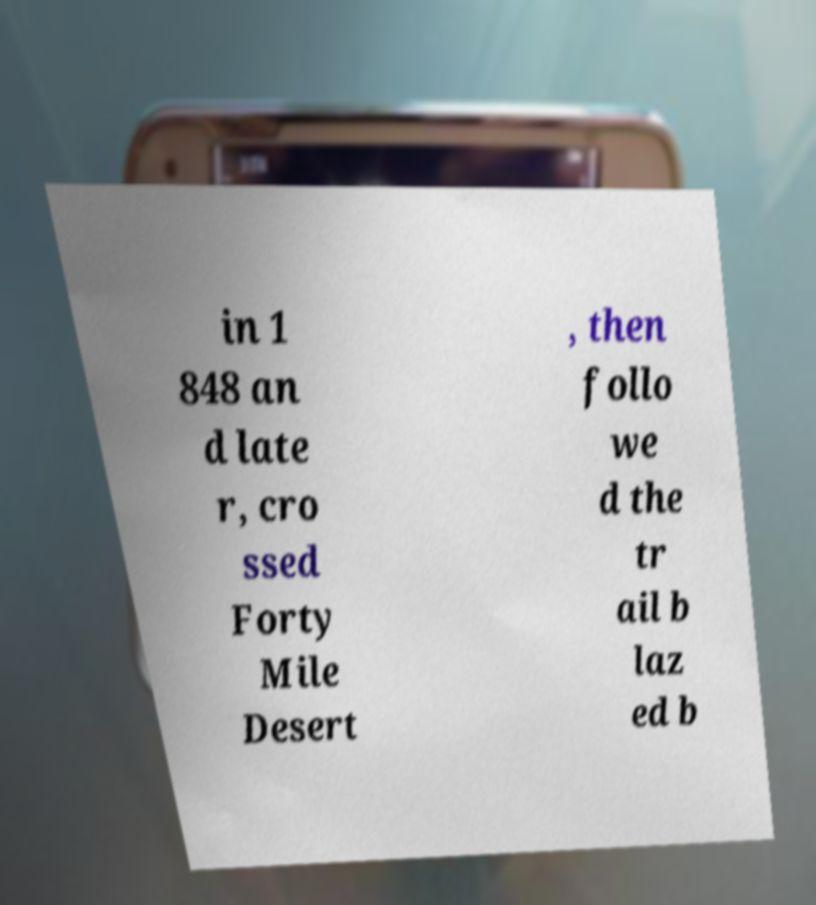What messages or text are displayed in this image? I need them in a readable, typed format. in 1 848 an d late r, cro ssed Forty Mile Desert , then follo we d the tr ail b laz ed b 